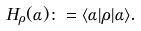Convert formula to latex. <formula><loc_0><loc_0><loc_500><loc_500>H _ { \rho } ( \alpha ) \colon = \langle \alpha | \rho | \alpha \rangle .</formula> 